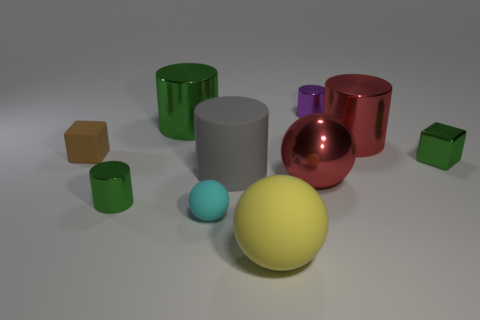What shape is the rubber object that is both left of the gray matte cylinder and right of the tiny brown cube?
Make the answer very short. Sphere. Are there any other things that are the same shape as the big green shiny object?
Give a very brief answer. Yes. What is the color of the large rubber object that is the same shape as the large green metallic object?
Keep it short and to the point. Gray. Do the brown rubber cube and the gray rubber cylinder have the same size?
Provide a succinct answer. No. What number of other objects are the same size as the cyan rubber object?
Your answer should be very brief. 4. What number of things are big red objects that are behind the tiny brown object or rubber objects to the right of the brown cube?
Offer a very short reply. 4. The cyan object that is the same size as the brown matte thing is what shape?
Give a very brief answer. Sphere. What size is the red thing that is the same material as the red sphere?
Ensure brevity in your answer.  Large. Do the tiny brown rubber thing and the cyan rubber thing have the same shape?
Your answer should be compact. No. There is a matte block that is the same size as the cyan sphere; what is its color?
Offer a very short reply. Brown. 